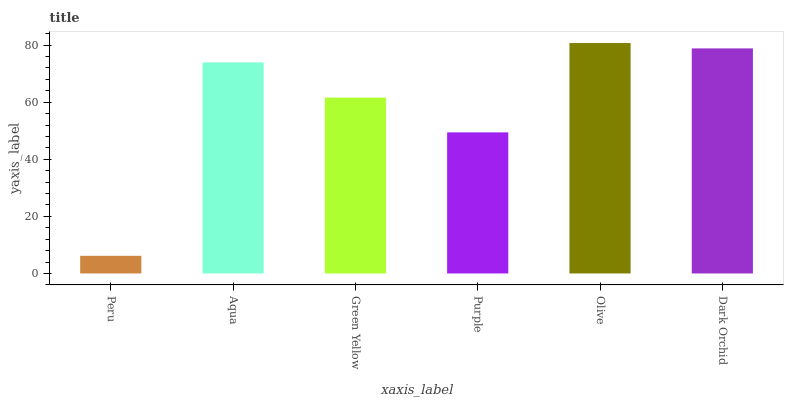Is Peru the minimum?
Answer yes or no. Yes. Is Olive the maximum?
Answer yes or no. Yes. Is Aqua the minimum?
Answer yes or no. No. Is Aqua the maximum?
Answer yes or no. No. Is Aqua greater than Peru?
Answer yes or no. Yes. Is Peru less than Aqua?
Answer yes or no. Yes. Is Peru greater than Aqua?
Answer yes or no. No. Is Aqua less than Peru?
Answer yes or no. No. Is Aqua the high median?
Answer yes or no. Yes. Is Green Yellow the low median?
Answer yes or no. Yes. Is Purple the high median?
Answer yes or no. No. Is Purple the low median?
Answer yes or no. No. 